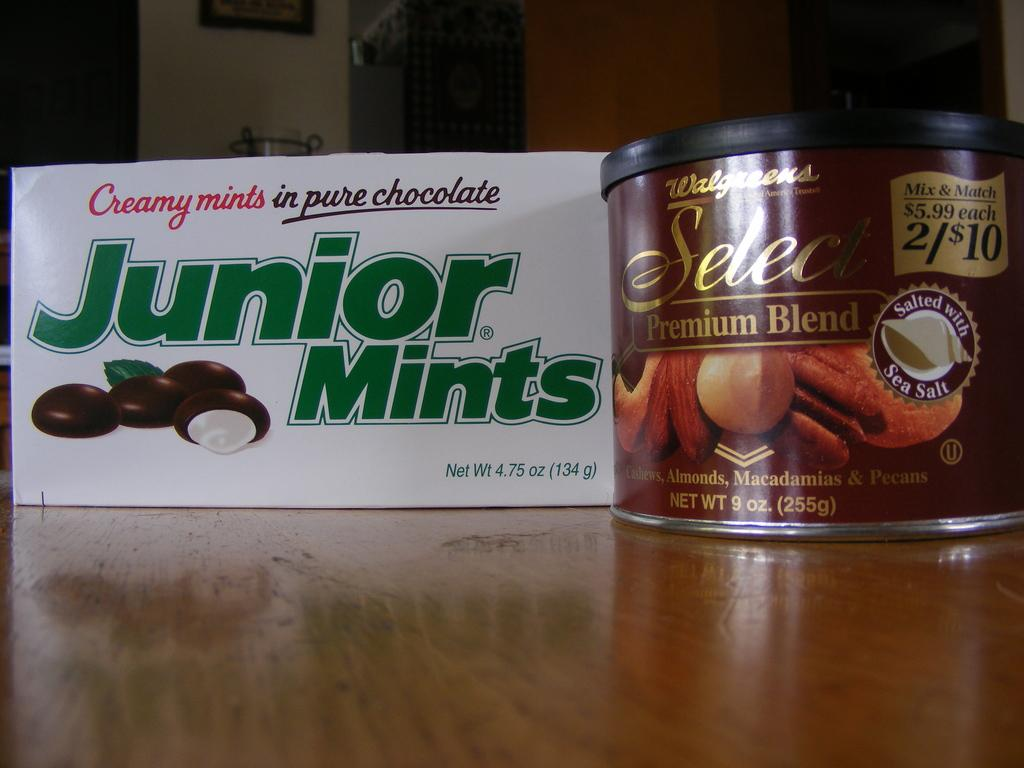What objects can be seen in the image? There is a box and a board in the image. What is the color of the surface on which the box and board are placed? The box and board are on a brown color surface. Can you describe anything visible on the wall in the background of the image? There is a frame visible on the wall in the background of the image. How much money is inside the locket hanging from the frame in the image? There is no locket or money present in the image. What type of cemetery can be seen in the background of the image? There is no cemetery visible in the image; it only features a frame on the wall in the background. 